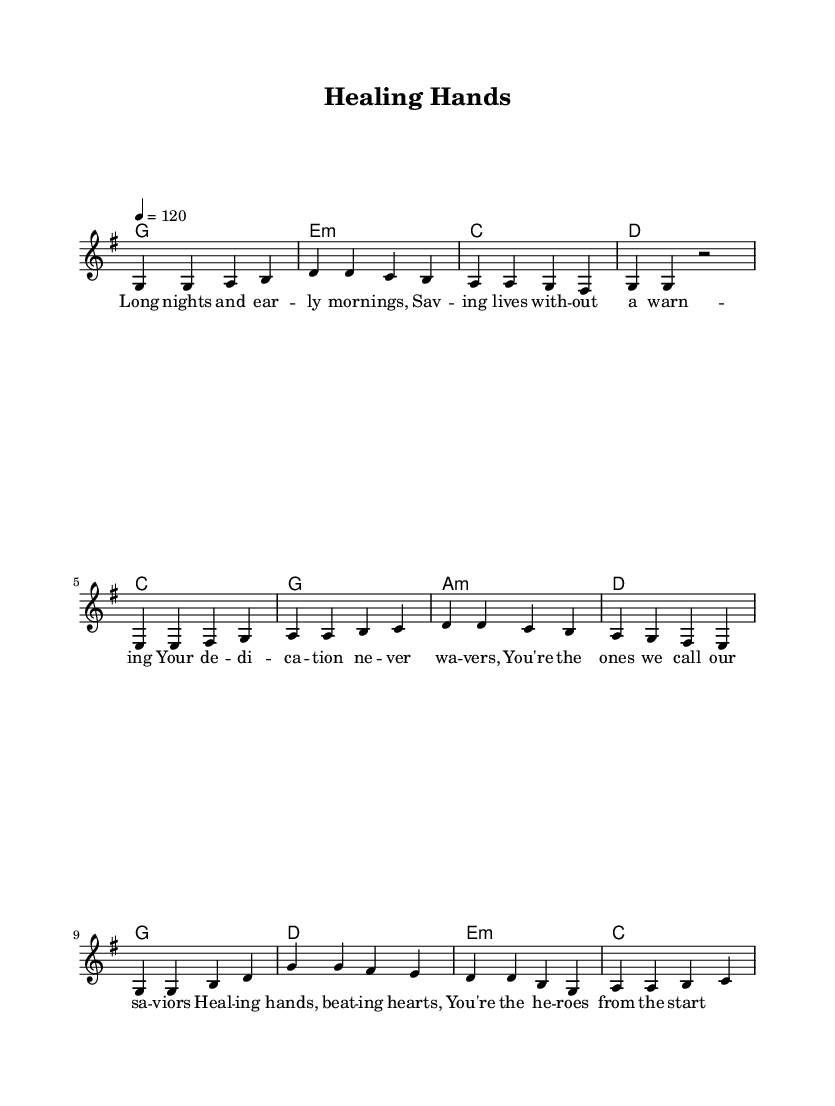What is the key signature of this music? The key signature is G major, which has one sharp (F#).
Answer: G major What is the time signature of this song? The time signature is 4/4, indicating four beats per measure.
Answer: 4/4 What is the tempo marking for this piece? The tempo is set at 120 beats per minute.
Answer: 120 How many measures are in the chorus section? The chorus consists of four measures, as indicated by the musical notation.
Answer: 4 What lyrical theming is expressed in the pre-chorus lyrics? The pre-chorus reflects appreciation and recognition of the dedication of healthcare workers.
Answer: Dedication How does the harmony change in the pre-chorus compared to the verse? The harmony in the pre-chorus introduces the chords C, G, A minor, and D, creating a shift from the verse's G, E minor, C, and D harmonies.
Answer: Different chords What are the prominent themes celebrated in the chorus? The chorus celebrates the healing work and heroism of healthcare workers.
Answer: Healing and heroism 